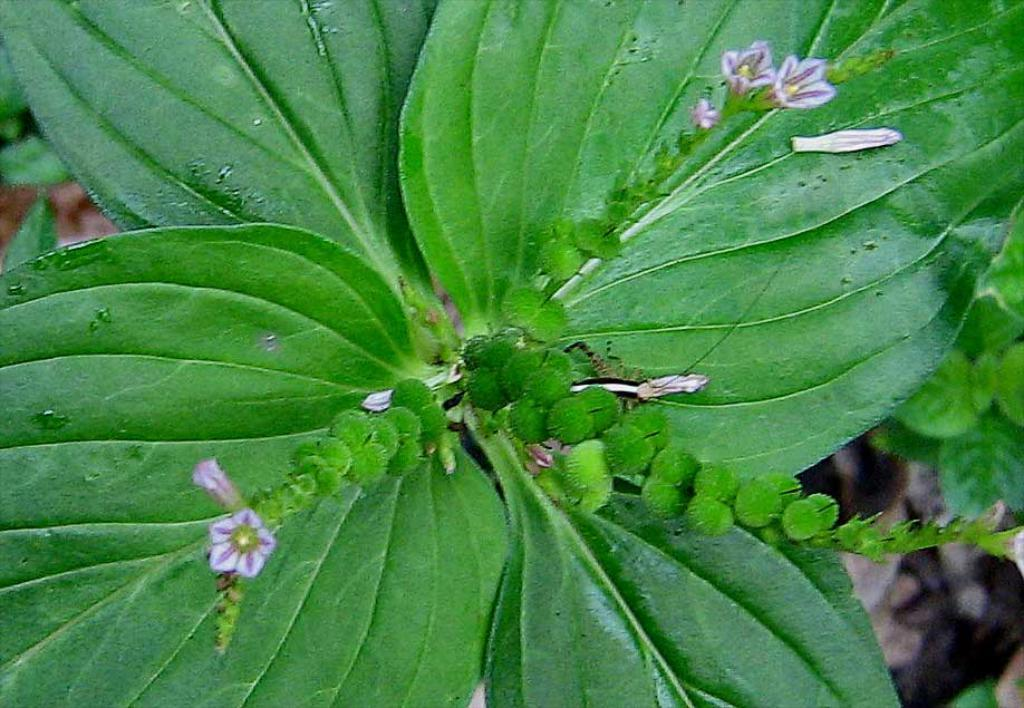What type of flowers are on the plant in the image? There are purple flowers on the plant. What else can be found on the plant besides flowers? There are fruits on the plant. What can be seen in the background of the image? There are trees visible in the background of the image. What type of meat is hanging from the tree in the image? There is no meat present in the image; it features a plant with purple flowers and fruits, as well as trees in the background. 